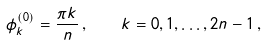Convert formula to latex. <formula><loc_0><loc_0><loc_500><loc_500>\phi _ { k } ^ { ( 0 ) } = \frac { \pi k } { n } \, , \quad k = 0 , 1 , \dots , 2 n - 1 \, ,</formula> 